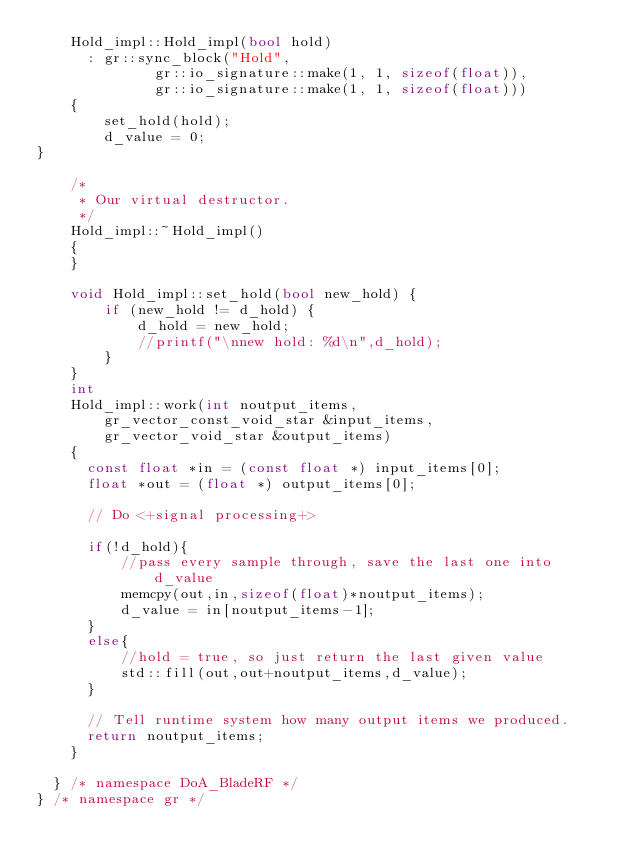<code> <loc_0><loc_0><loc_500><loc_500><_C++_>    Hold_impl::Hold_impl(bool hold)
      : gr::sync_block("Hold",
              gr::io_signature::make(1, 1, sizeof(float)),
              gr::io_signature::make(1, 1, sizeof(float)))
    {
        set_hold(hold);
        d_value = 0;
}

    /*
     * Our virtual destructor.
     */
    Hold_impl::~Hold_impl()
    {
    }

    void Hold_impl::set_hold(bool new_hold) {
        if (new_hold != d_hold) {
            d_hold = new_hold;
            //printf("\nnew hold: %d\n",d_hold);
        }
    }
    int
    Hold_impl::work(int noutput_items,
        gr_vector_const_void_star &input_items,
        gr_vector_void_star &output_items)
    {
      const float *in = (const float *) input_items[0];
      float *out = (float *) output_items[0];

      // Do <+signal processing+>

      if(!d_hold){
          //pass every sample through, save the last one into d_value
          memcpy(out,in,sizeof(float)*noutput_items);
          d_value = in[noutput_items-1];
      }
      else{
          //hold = true, so just return the last given value
          std::fill(out,out+noutput_items,d_value);
      }

      // Tell runtime system how many output items we produced.
      return noutput_items;
    }

  } /* namespace DoA_BladeRF */
} /* namespace gr */

</code> 